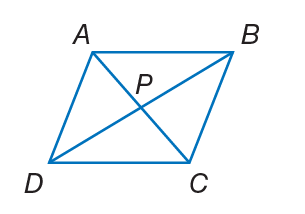Answer the mathemtical geometry problem and directly provide the correct option letter.
Question: A B C D is a rhombus. If P B = 12, A B = 15, and m \angle A B D = 24. Find A P.
Choices: A: 9 B: 14 C: 56 D: 97 A 